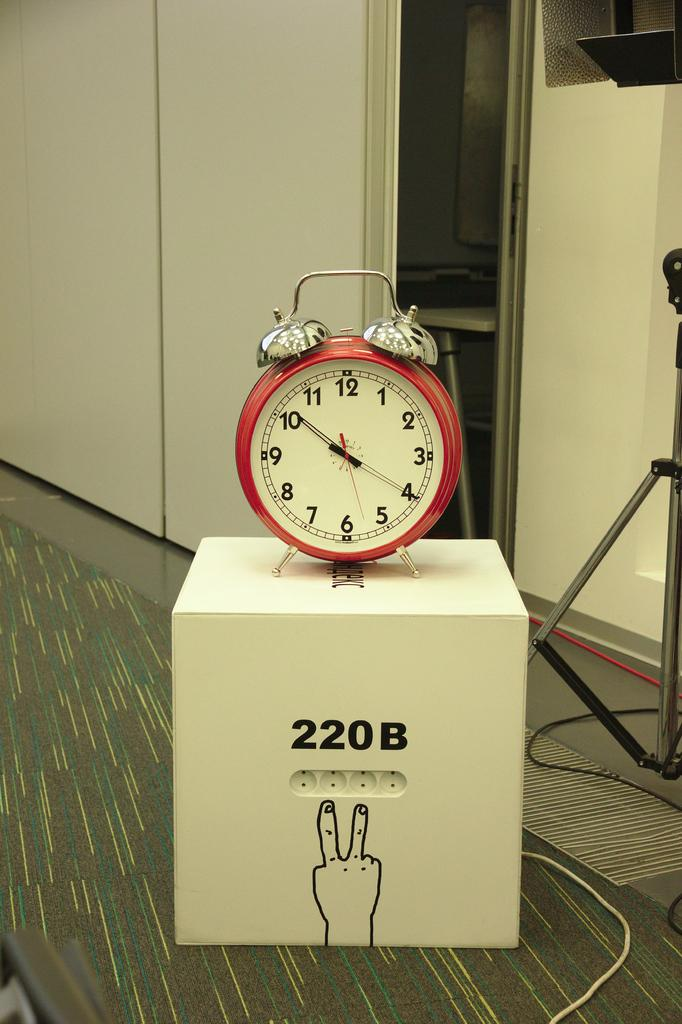<image>
Create a compact narrative representing the image presented. Red clock on top of a box that says 220B. 